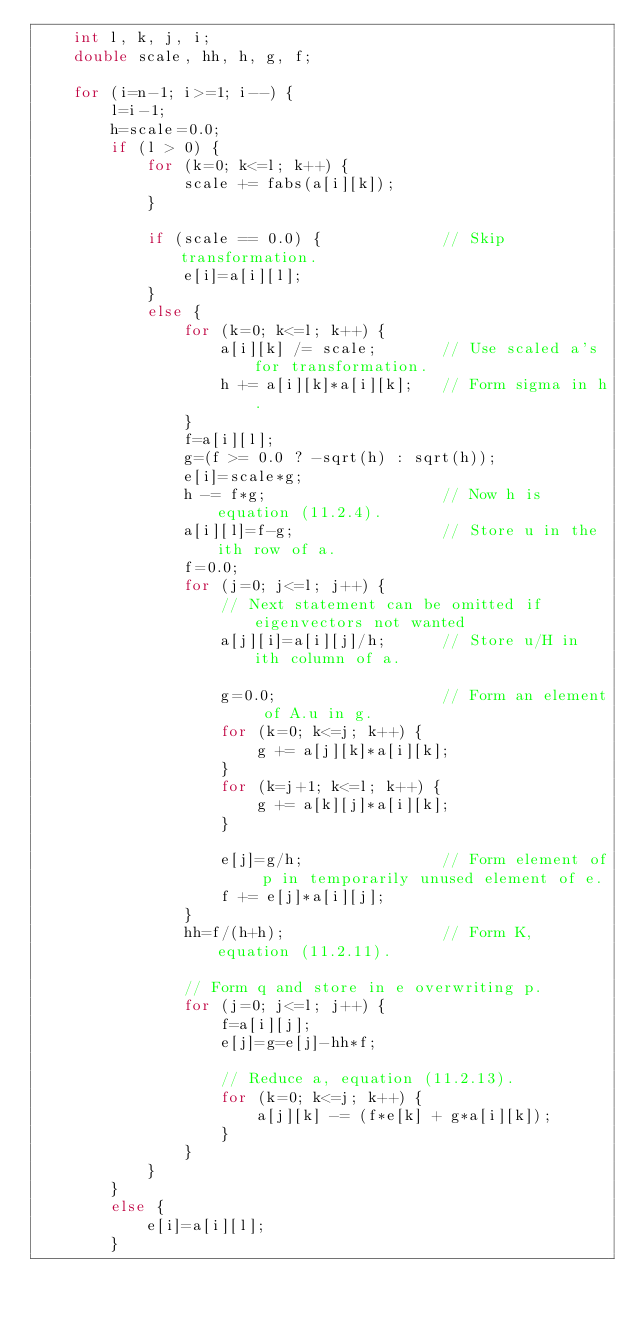Convert code to text. <code><loc_0><loc_0><loc_500><loc_500><_C++_>    int l, k, j, i;
    double scale, hh, h, g, f;

    for (i=n-1; i>=1; i--) {
        l=i-1;
        h=scale=0.0;
        if (l > 0) {
            for (k=0; k<=l; k++) {
                scale += fabs(a[i][k]);
            }

            if (scale == 0.0) {             // Skip transformation.
                e[i]=a[i][l];
            }
            else {
                for (k=0; k<=l; k++) {
                    a[i][k] /= scale;       // Use scaled a's for transformation.
                    h += a[i][k]*a[i][k];   // Form sigma in h.
                }
                f=a[i][l];
                g=(f >= 0.0 ? -sqrt(h) : sqrt(h));
                e[i]=scale*g;
                h -= f*g;                   // Now h is equation (11.2.4).
                a[i][l]=f-g;                // Store u in the ith row of a.
                f=0.0;
                for (j=0; j<=l; j++) {
                    // Next statement can be omitted if eigenvectors not wanted
                    a[j][i]=a[i][j]/h;      // Store u/H in ith column of a.

                    g=0.0;                  // Form an element of A.u in g.
                    for (k=0; k<=j; k++) {
                        g += a[j][k]*a[i][k];
                    }
                    for (k=j+1; k<=l; k++) {
                        g += a[k][j]*a[i][k];
                    }

                    e[j]=g/h;               // Form element of p in temporarily unused element of e.
                    f += e[j]*a[i][j];
                }
                hh=f/(h+h);                 // Form K, equation (11.2.11).

                // Form q and store in e overwriting p.
                for (j=0; j<=l; j++) {
                    f=a[i][j];
                    e[j]=g=e[j]-hh*f;

                    // Reduce a, equation (11.2.13).
                    for (k=0; k<=j; k++) {
                        a[j][k] -= (f*e[k] + g*a[i][k]);
                    }
                }
            }
        }
        else {
            e[i]=a[i][l];
        }</code> 